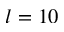<formula> <loc_0><loc_0><loc_500><loc_500>l = 1 0</formula> 